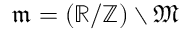Convert formula to latex. <formula><loc_0><loc_0><loc_500><loc_500>{ \mathfrak { m } } = ( \mathbb { R } / \mathbb { Z } ) \ { \mathfrak { M } }</formula> 